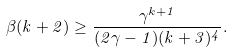<formula> <loc_0><loc_0><loc_500><loc_500>\beta ( k + 2 ) \geq \frac { \gamma ^ { k + 1 } } { ( 2 \gamma - 1 ) ( k + 3 ) ^ { 4 } } .</formula> 